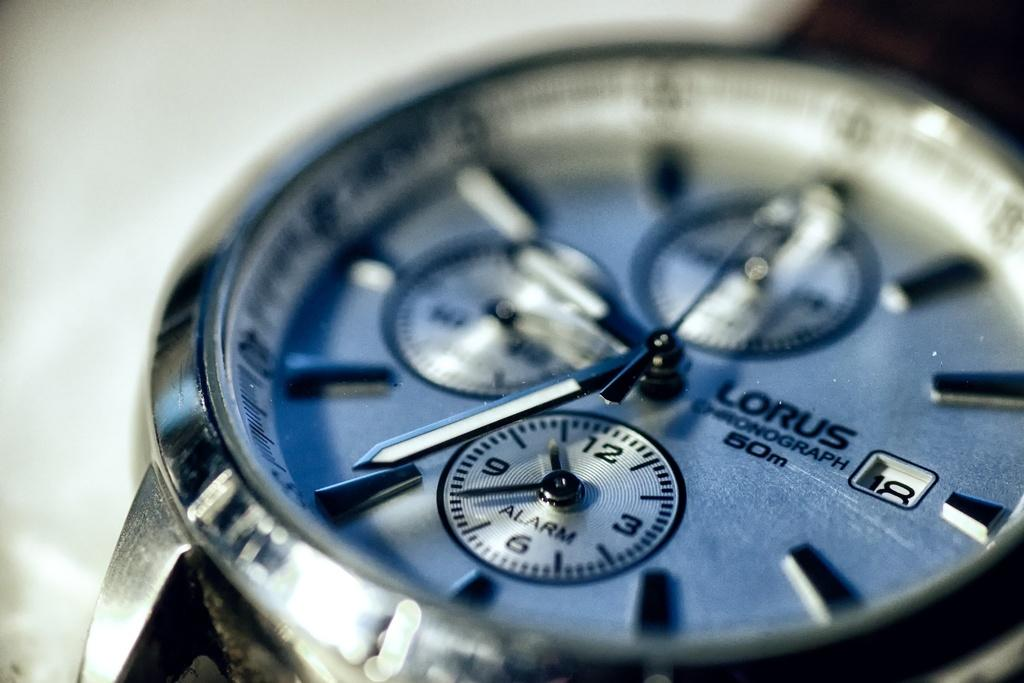<image>
Summarize the visual content of the image. a close up of a Lorus silver watch with blue face 